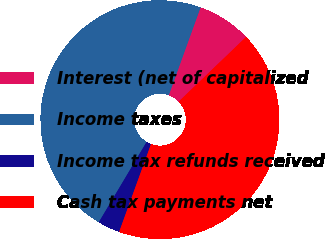Convert chart to OTSL. <chart><loc_0><loc_0><loc_500><loc_500><pie_chart><fcel>Interest (net of capitalized<fcel>Income taxes<fcel>Income tax refunds received<fcel>Cash tax payments net<nl><fcel>7.3%<fcel>46.98%<fcel>3.01%<fcel>42.71%<nl></chart> 